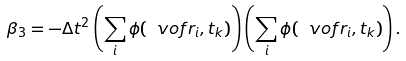<formula> <loc_0><loc_0><loc_500><loc_500>\beta _ { 3 } = - \Delta t ^ { 2 } \left ( \sum _ { i } \phi ( \ v o f r _ { i } , t _ { k } ) \right ) \left ( \sum _ { i } \phi ( \ v o f r _ { i } , t _ { k } ) \right ) . \\</formula> 